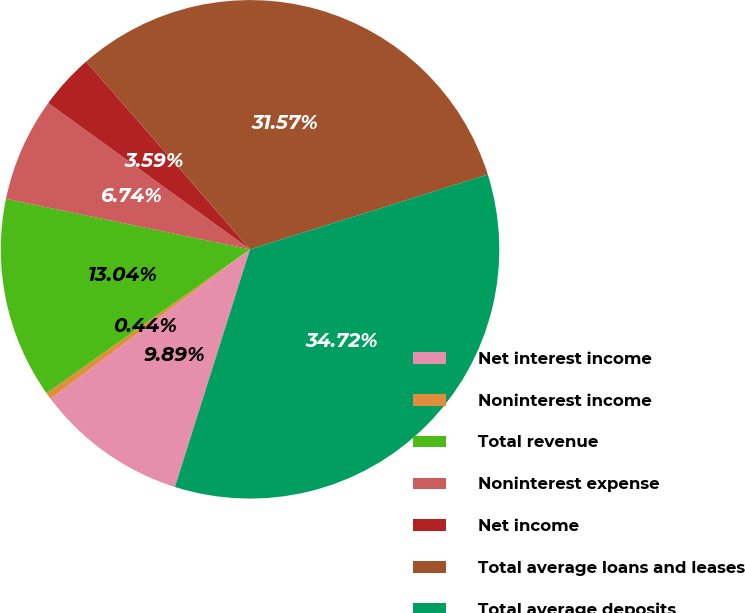Convert chart. <chart><loc_0><loc_0><loc_500><loc_500><pie_chart><fcel>Net interest income<fcel>Noninterest income<fcel>Total revenue<fcel>Noninterest expense<fcel>Net income<fcel>Total average loans and leases<fcel>Total average deposits<nl><fcel>9.89%<fcel>0.44%<fcel>13.04%<fcel>6.74%<fcel>3.59%<fcel>31.57%<fcel>34.72%<nl></chart> 